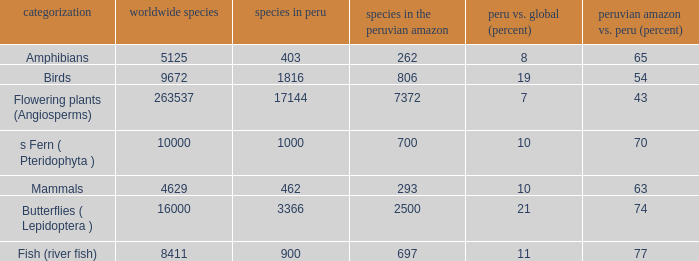What's the total number of species in the peruvian amazon with 8411 species in the world  1.0. 